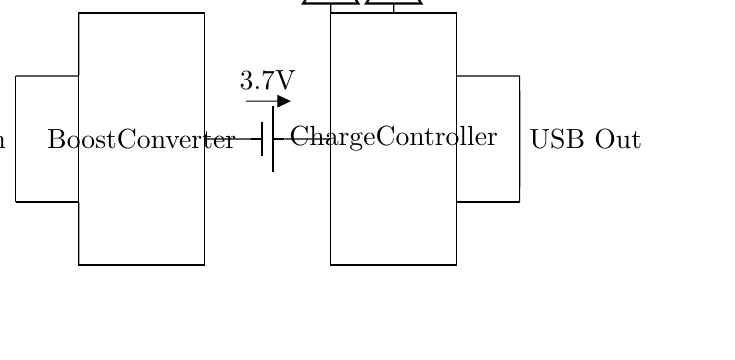What is the input voltage for this power bank? The input voltage is not explicitly labeled but is typically 5V for USB devices; therefore, we can infer that this power bank is designed to accept a standard USB input voltage.
Answer: 5V What is the battery voltage in this circuit? The battery in the circuit is specified as having a voltage of 3.7V, as indicated by the label next to the battery symbol.
Answer: 3.7V What component is responsible for increasing the voltage? The component that increases the voltage is the Boost Converter, which is labeled as such in the circuit diagram. It is positioned between the battery and the charge controller, indicating its role in stepping up the voltage from the battery to the output level.
Answer: Boost Converter What do the LEDs indicate in this circuit? The circuit has two LEDs: one labeled as "Power LED" and the other as "Charging LED." The Power LED represents that the device is powered on, while the Charging LED indicates that the device is currently charging.
Answer: Power LED and Charging LED Why is a Charge Controller used in this circuit? The Charge Controller manages the charging process of the battery to ensure it is charged safely and efficiently. It regulates the voltage and current supplied to the battery while also preventing overcharging, which could damage the battery.
Answer: To manage charging safely 